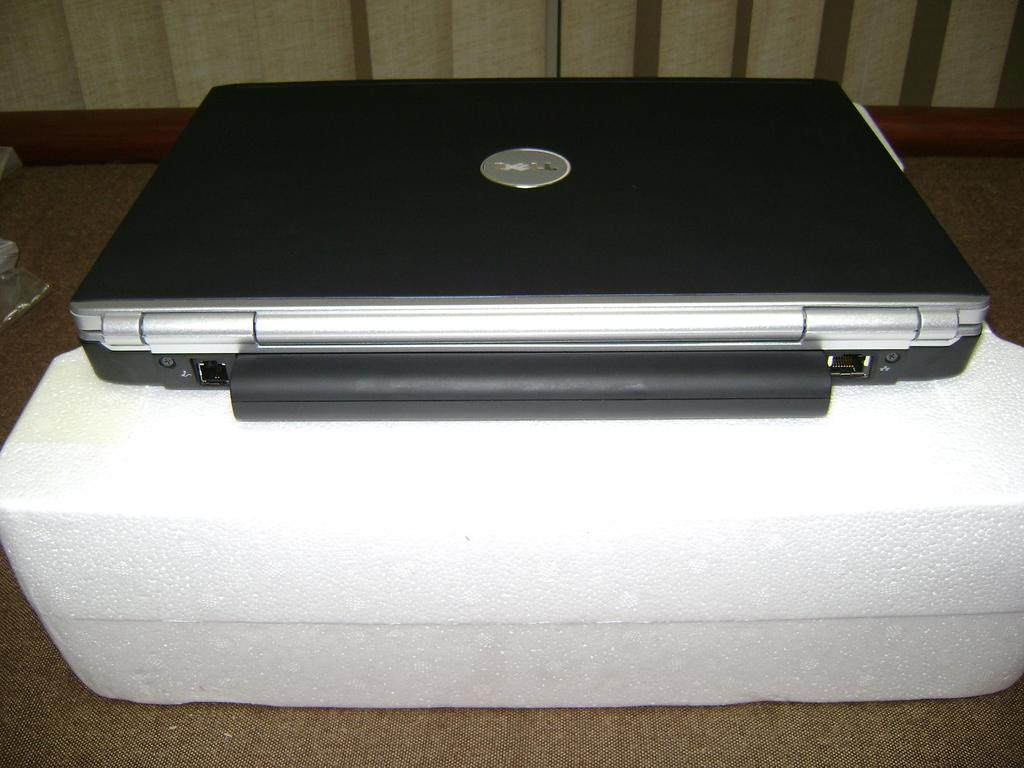What type of electronic device is in the image? There is a netbook in the image. Where is the netbook located in the image? The netbook is in the center of the image. What is the netbook placed on in the image? The netbook is on a polystyrene. How many cherries are hanging from the kite in the image? There are no cherries or kite present in the image. What type of journey is the netbook taking in the image? The netbook is not taking any journey in the image; it is stationary on a polystyrene. 